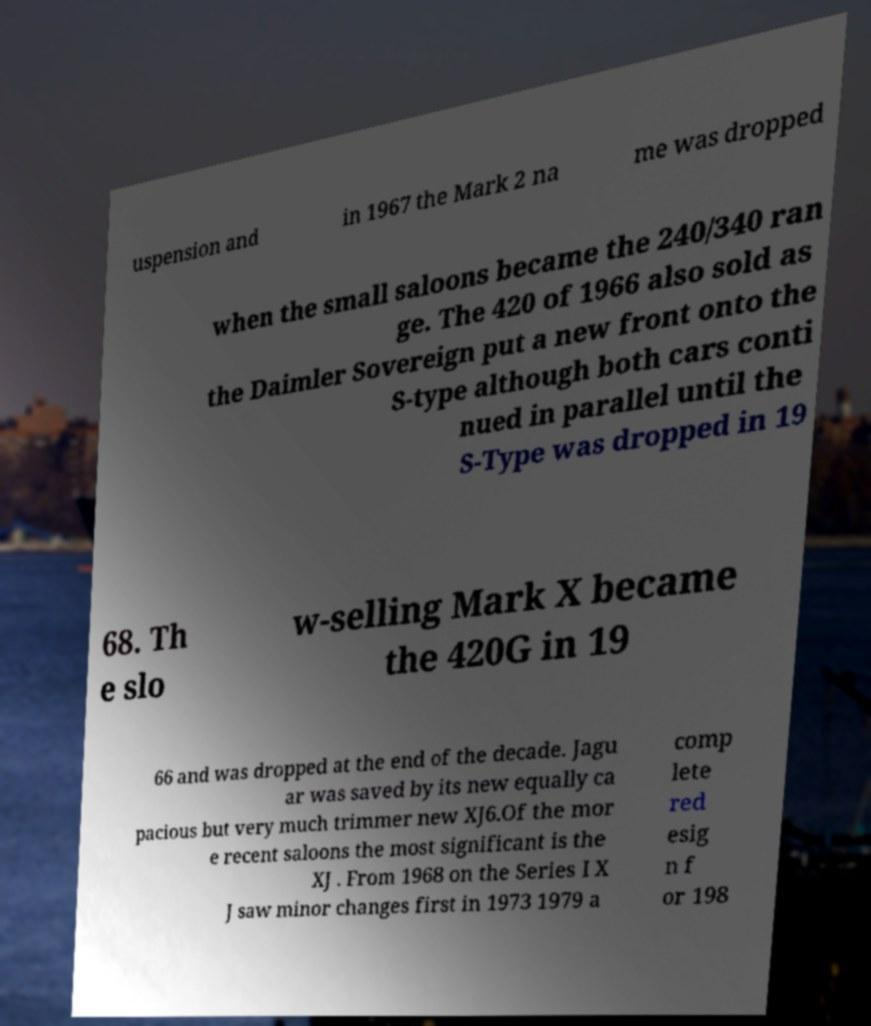What messages or text are displayed in this image? I need them in a readable, typed format. uspension and in 1967 the Mark 2 na me was dropped when the small saloons became the 240/340 ran ge. The 420 of 1966 also sold as the Daimler Sovereign put a new front onto the S-type although both cars conti nued in parallel until the S-Type was dropped in 19 68. Th e slo w-selling Mark X became the 420G in 19 66 and was dropped at the end of the decade. Jagu ar was saved by its new equally ca pacious but very much trimmer new XJ6.Of the mor e recent saloons the most significant is the XJ . From 1968 on the Series I X J saw minor changes first in 1973 1979 a comp lete red esig n f or 198 